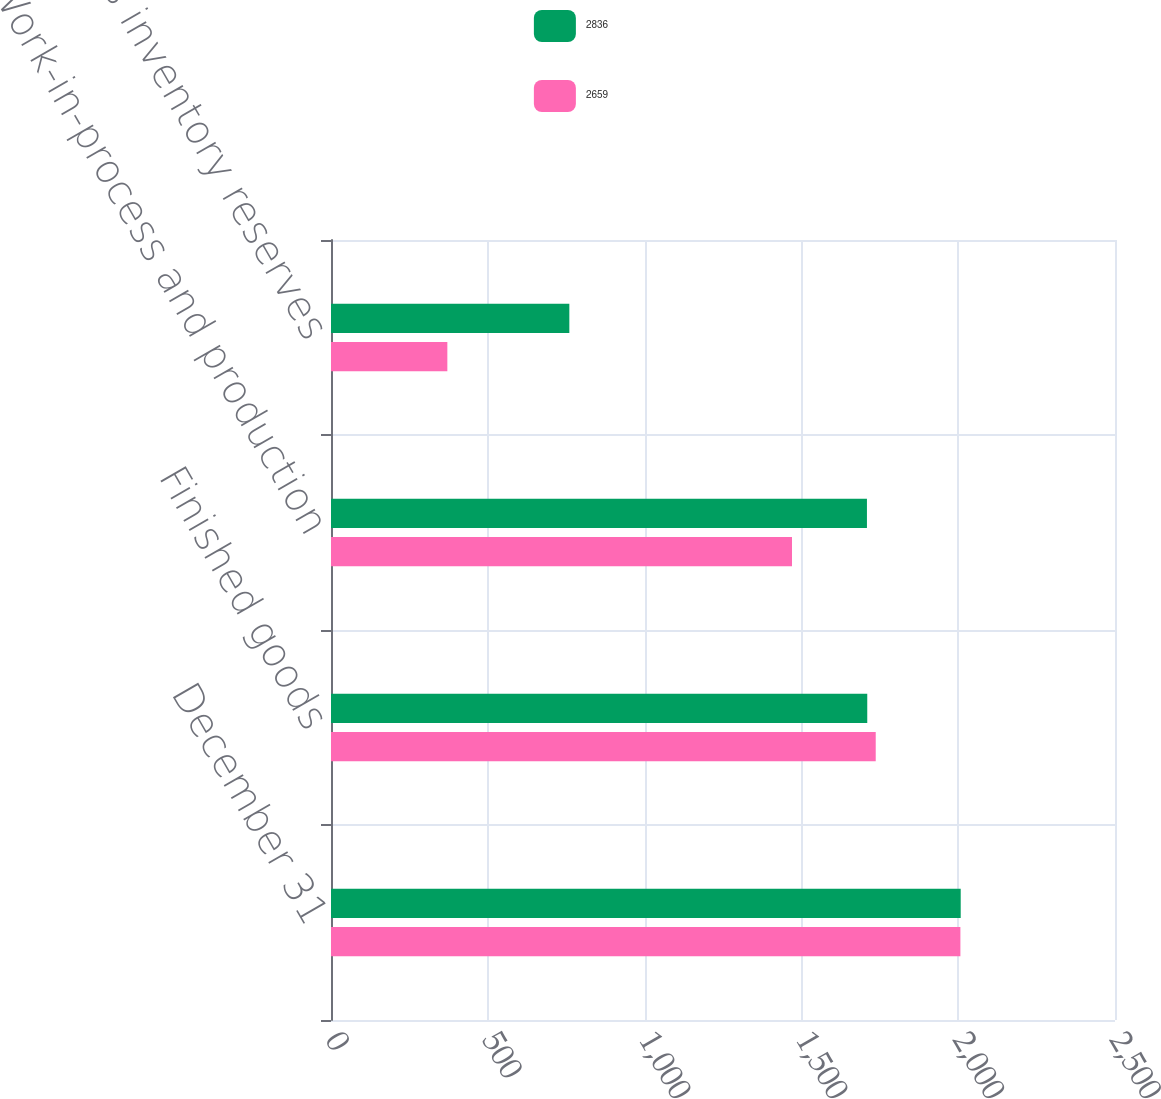<chart> <loc_0><loc_0><loc_500><loc_500><stacked_bar_chart><ecel><fcel>December 31<fcel>Finished goods<fcel>Work-in-process and production<fcel>Less inventory reserves<nl><fcel>2836<fcel>2008<fcel>1710<fcel>1709<fcel>760<nl><fcel>2659<fcel>2007<fcel>1737<fcel>1470<fcel>371<nl></chart> 